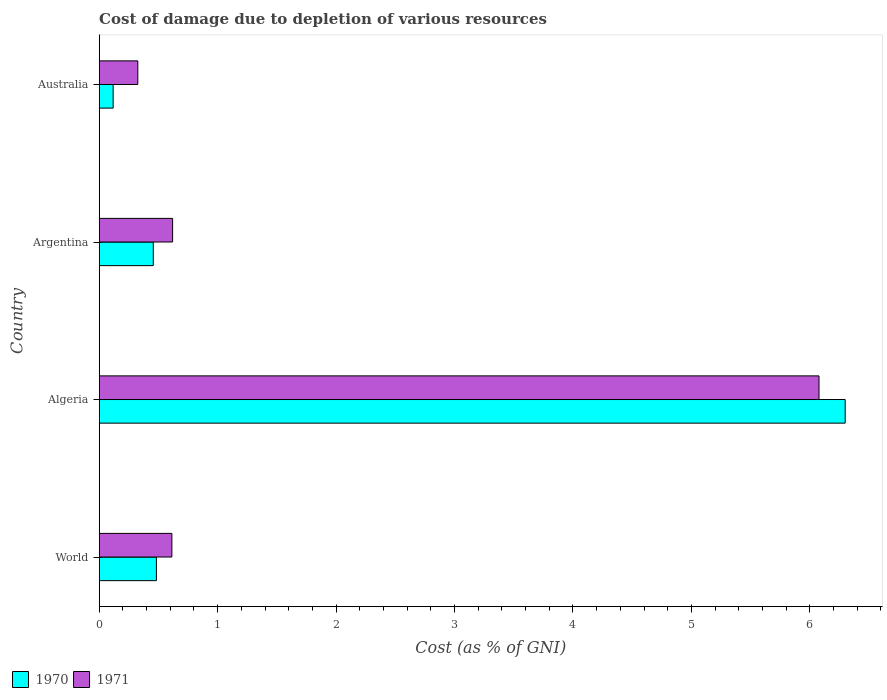How many different coloured bars are there?
Offer a very short reply. 2. Are the number of bars per tick equal to the number of legend labels?
Provide a succinct answer. Yes. Are the number of bars on each tick of the Y-axis equal?
Your response must be concise. Yes. What is the label of the 3rd group of bars from the top?
Provide a succinct answer. Algeria. In how many cases, is the number of bars for a given country not equal to the number of legend labels?
Give a very brief answer. 0. What is the cost of damage caused due to the depletion of various resources in 1971 in Algeria?
Make the answer very short. 6.08. Across all countries, what is the maximum cost of damage caused due to the depletion of various resources in 1971?
Your response must be concise. 6.08. Across all countries, what is the minimum cost of damage caused due to the depletion of various resources in 1971?
Keep it short and to the point. 0.33. In which country was the cost of damage caused due to the depletion of various resources in 1970 maximum?
Provide a succinct answer. Algeria. What is the total cost of damage caused due to the depletion of various resources in 1970 in the graph?
Offer a terse response. 7.36. What is the difference between the cost of damage caused due to the depletion of various resources in 1971 in Algeria and that in World?
Your answer should be compact. 5.46. What is the difference between the cost of damage caused due to the depletion of various resources in 1971 in World and the cost of damage caused due to the depletion of various resources in 1970 in Australia?
Offer a terse response. 0.5. What is the average cost of damage caused due to the depletion of various resources in 1971 per country?
Provide a short and direct response. 1.91. What is the difference between the cost of damage caused due to the depletion of various resources in 1971 and cost of damage caused due to the depletion of various resources in 1970 in Algeria?
Your response must be concise. -0.22. In how many countries, is the cost of damage caused due to the depletion of various resources in 1971 greater than 3.2 %?
Give a very brief answer. 1. What is the ratio of the cost of damage caused due to the depletion of various resources in 1970 in Algeria to that in World?
Provide a succinct answer. 13.04. Is the cost of damage caused due to the depletion of various resources in 1971 in Australia less than that in World?
Provide a succinct answer. Yes. Is the difference between the cost of damage caused due to the depletion of various resources in 1971 in Argentina and Australia greater than the difference between the cost of damage caused due to the depletion of various resources in 1970 in Argentina and Australia?
Make the answer very short. No. What is the difference between the highest and the second highest cost of damage caused due to the depletion of various resources in 1970?
Give a very brief answer. 5.82. What is the difference between the highest and the lowest cost of damage caused due to the depletion of various resources in 1970?
Provide a succinct answer. 6.18. What does the 2nd bar from the top in World represents?
Your answer should be very brief. 1970. What is the difference between two consecutive major ticks on the X-axis?
Offer a terse response. 1. Are the values on the major ticks of X-axis written in scientific E-notation?
Make the answer very short. No. Where does the legend appear in the graph?
Your response must be concise. Bottom left. How many legend labels are there?
Make the answer very short. 2. How are the legend labels stacked?
Provide a succinct answer. Horizontal. What is the title of the graph?
Your answer should be compact. Cost of damage due to depletion of various resources. Does "1981" appear as one of the legend labels in the graph?
Provide a short and direct response. No. What is the label or title of the X-axis?
Provide a succinct answer. Cost (as % of GNI). What is the Cost (as % of GNI) of 1970 in World?
Your answer should be compact. 0.48. What is the Cost (as % of GNI) of 1971 in World?
Offer a very short reply. 0.61. What is the Cost (as % of GNI) of 1970 in Algeria?
Keep it short and to the point. 6.3. What is the Cost (as % of GNI) of 1971 in Algeria?
Your response must be concise. 6.08. What is the Cost (as % of GNI) in 1970 in Argentina?
Ensure brevity in your answer.  0.46. What is the Cost (as % of GNI) in 1971 in Argentina?
Make the answer very short. 0.62. What is the Cost (as % of GNI) of 1970 in Australia?
Offer a terse response. 0.12. What is the Cost (as % of GNI) of 1971 in Australia?
Make the answer very short. 0.33. Across all countries, what is the maximum Cost (as % of GNI) in 1970?
Your answer should be compact. 6.3. Across all countries, what is the maximum Cost (as % of GNI) in 1971?
Your answer should be very brief. 6.08. Across all countries, what is the minimum Cost (as % of GNI) of 1970?
Give a very brief answer. 0.12. Across all countries, what is the minimum Cost (as % of GNI) in 1971?
Your response must be concise. 0.33. What is the total Cost (as % of GNI) of 1970 in the graph?
Ensure brevity in your answer.  7.36. What is the total Cost (as % of GNI) of 1971 in the graph?
Provide a succinct answer. 7.64. What is the difference between the Cost (as % of GNI) in 1970 in World and that in Algeria?
Make the answer very short. -5.82. What is the difference between the Cost (as % of GNI) in 1971 in World and that in Algeria?
Give a very brief answer. -5.46. What is the difference between the Cost (as % of GNI) of 1970 in World and that in Argentina?
Give a very brief answer. 0.03. What is the difference between the Cost (as % of GNI) in 1971 in World and that in Argentina?
Make the answer very short. -0.01. What is the difference between the Cost (as % of GNI) in 1970 in World and that in Australia?
Make the answer very short. 0.37. What is the difference between the Cost (as % of GNI) in 1971 in World and that in Australia?
Offer a very short reply. 0.29. What is the difference between the Cost (as % of GNI) in 1970 in Algeria and that in Argentina?
Your answer should be very brief. 5.84. What is the difference between the Cost (as % of GNI) in 1971 in Algeria and that in Argentina?
Offer a very short reply. 5.46. What is the difference between the Cost (as % of GNI) of 1970 in Algeria and that in Australia?
Offer a terse response. 6.18. What is the difference between the Cost (as % of GNI) in 1971 in Algeria and that in Australia?
Your answer should be compact. 5.75. What is the difference between the Cost (as % of GNI) of 1970 in Argentina and that in Australia?
Offer a very short reply. 0.34. What is the difference between the Cost (as % of GNI) of 1971 in Argentina and that in Australia?
Make the answer very short. 0.29. What is the difference between the Cost (as % of GNI) of 1970 in World and the Cost (as % of GNI) of 1971 in Algeria?
Provide a short and direct response. -5.59. What is the difference between the Cost (as % of GNI) of 1970 in World and the Cost (as % of GNI) of 1971 in Argentina?
Your answer should be very brief. -0.14. What is the difference between the Cost (as % of GNI) of 1970 in World and the Cost (as % of GNI) of 1971 in Australia?
Your answer should be very brief. 0.16. What is the difference between the Cost (as % of GNI) in 1970 in Algeria and the Cost (as % of GNI) in 1971 in Argentina?
Your answer should be very brief. 5.68. What is the difference between the Cost (as % of GNI) in 1970 in Algeria and the Cost (as % of GNI) in 1971 in Australia?
Give a very brief answer. 5.97. What is the difference between the Cost (as % of GNI) of 1970 in Argentina and the Cost (as % of GNI) of 1971 in Australia?
Offer a very short reply. 0.13. What is the average Cost (as % of GNI) in 1970 per country?
Give a very brief answer. 1.84. What is the average Cost (as % of GNI) in 1971 per country?
Keep it short and to the point. 1.91. What is the difference between the Cost (as % of GNI) of 1970 and Cost (as % of GNI) of 1971 in World?
Offer a very short reply. -0.13. What is the difference between the Cost (as % of GNI) of 1970 and Cost (as % of GNI) of 1971 in Algeria?
Your response must be concise. 0.22. What is the difference between the Cost (as % of GNI) in 1970 and Cost (as % of GNI) in 1971 in Argentina?
Provide a short and direct response. -0.16. What is the difference between the Cost (as % of GNI) of 1970 and Cost (as % of GNI) of 1971 in Australia?
Provide a succinct answer. -0.21. What is the ratio of the Cost (as % of GNI) of 1970 in World to that in Algeria?
Offer a very short reply. 0.08. What is the ratio of the Cost (as % of GNI) of 1971 in World to that in Algeria?
Give a very brief answer. 0.1. What is the ratio of the Cost (as % of GNI) of 1970 in World to that in Argentina?
Ensure brevity in your answer.  1.06. What is the ratio of the Cost (as % of GNI) of 1970 in World to that in Australia?
Keep it short and to the point. 4.11. What is the ratio of the Cost (as % of GNI) in 1971 in World to that in Australia?
Your answer should be very brief. 1.88. What is the ratio of the Cost (as % of GNI) in 1970 in Algeria to that in Argentina?
Your response must be concise. 13.8. What is the ratio of the Cost (as % of GNI) of 1971 in Algeria to that in Argentina?
Your answer should be compact. 9.81. What is the ratio of the Cost (as % of GNI) of 1970 in Algeria to that in Australia?
Offer a very short reply. 53.61. What is the ratio of the Cost (as % of GNI) in 1971 in Algeria to that in Australia?
Your answer should be very brief. 18.65. What is the ratio of the Cost (as % of GNI) in 1970 in Argentina to that in Australia?
Your response must be concise. 3.89. What is the ratio of the Cost (as % of GNI) in 1971 in Argentina to that in Australia?
Provide a succinct answer. 1.9. What is the difference between the highest and the second highest Cost (as % of GNI) in 1970?
Make the answer very short. 5.82. What is the difference between the highest and the second highest Cost (as % of GNI) of 1971?
Your response must be concise. 5.46. What is the difference between the highest and the lowest Cost (as % of GNI) in 1970?
Provide a short and direct response. 6.18. What is the difference between the highest and the lowest Cost (as % of GNI) in 1971?
Give a very brief answer. 5.75. 